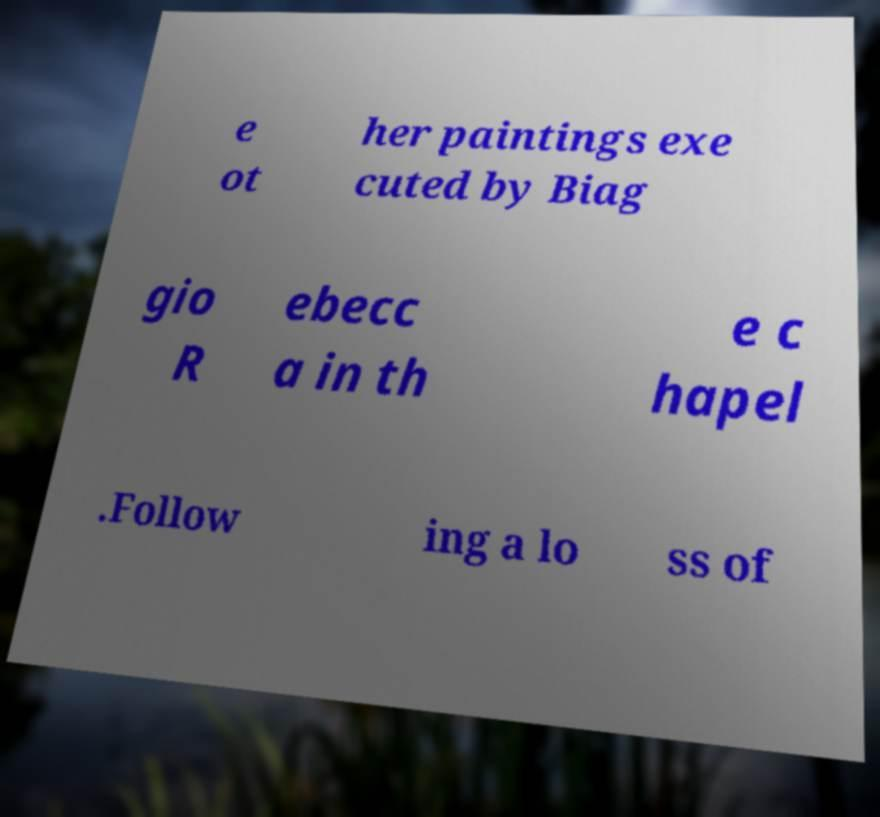Please read and relay the text visible in this image. What does it say? e ot her paintings exe cuted by Biag gio R ebecc a in th e c hapel .Follow ing a lo ss of 